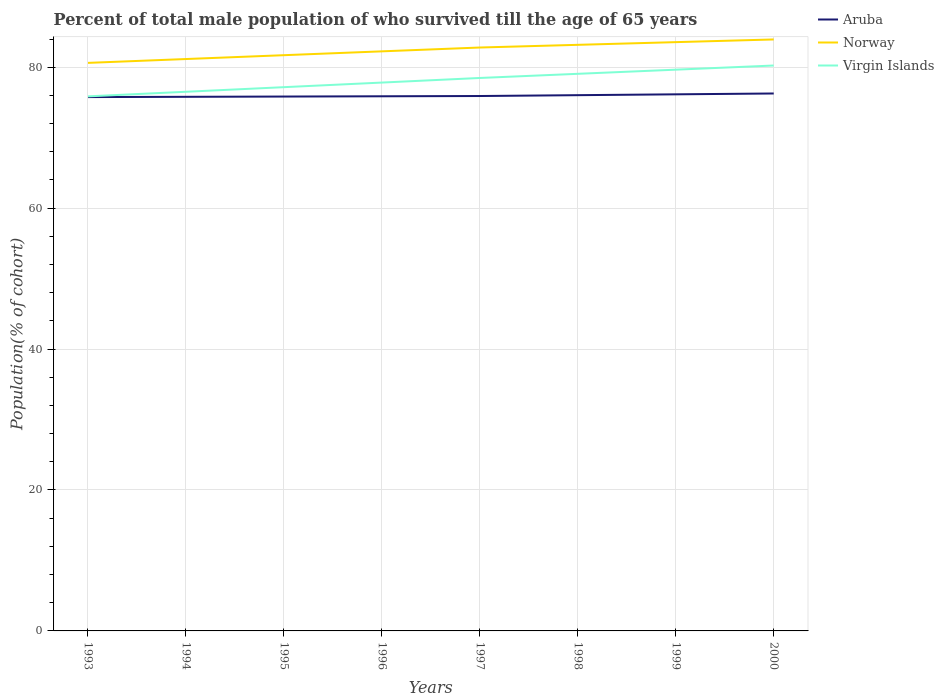How many different coloured lines are there?
Offer a very short reply. 3. Does the line corresponding to Virgin Islands intersect with the line corresponding to Aruba?
Provide a succinct answer. No. Is the number of lines equal to the number of legend labels?
Give a very brief answer. Yes. Across all years, what is the maximum percentage of total male population who survived till the age of 65 years in Norway?
Keep it short and to the point. 80.62. In which year was the percentage of total male population who survived till the age of 65 years in Virgin Islands maximum?
Offer a very short reply. 1993. What is the total percentage of total male population who survived till the age of 65 years in Norway in the graph?
Make the answer very short. -0.38. What is the difference between the highest and the second highest percentage of total male population who survived till the age of 65 years in Norway?
Your response must be concise. 3.32. What is the difference between the highest and the lowest percentage of total male population who survived till the age of 65 years in Norway?
Your answer should be very brief. 4. Is the percentage of total male population who survived till the age of 65 years in Virgin Islands strictly greater than the percentage of total male population who survived till the age of 65 years in Norway over the years?
Keep it short and to the point. Yes. How many lines are there?
Give a very brief answer. 3. What is the difference between two consecutive major ticks on the Y-axis?
Offer a very short reply. 20. Does the graph contain grids?
Your answer should be compact. Yes. Where does the legend appear in the graph?
Ensure brevity in your answer.  Top right. How many legend labels are there?
Your answer should be very brief. 3. What is the title of the graph?
Make the answer very short. Percent of total male population of who survived till the age of 65 years. What is the label or title of the X-axis?
Provide a succinct answer. Years. What is the label or title of the Y-axis?
Provide a short and direct response. Population(% of cohort). What is the Population(% of cohort) of Aruba in 1993?
Keep it short and to the point. 75.76. What is the Population(% of cohort) of Norway in 1993?
Give a very brief answer. 80.62. What is the Population(% of cohort) in Virgin Islands in 1993?
Provide a succinct answer. 75.87. What is the Population(% of cohort) in Aruba in 1994?
Provide a succinct answer. 75.8. What is the Population(% of cohort) in Norway in 1994?
Give a very brief answer. 81.16. What is the Population(% of cohort) of Virgin Islands in 1994?
Your response must be concise. 76.52. What is the Population(% of cohort) of Aruba in 1995?
Offer a terse response. 75.84. What is the Population(% of cohort) of Norway in 1995?
Your answer should be compact. 81.71. What is the Population(% of cohort) in Virgin Islands in 1995?
Your answer should be compact. 77.17. What is the Population(% of cohort) of Aruba in 1996?
Provide a short and direct response. 75.88. What is the Population(% of cohort) of Norway in 1996?
Give a very brief answer. 82.25. What is the Population(% of cohort) of Virgin Islands in 1996?
Provide a short and direct response. 77.82. What is the Population(% of cohort) of Aruba in 1997?
Provide a succinct answer. 75.92. What is the Population(% of cohort) of Norway in 1997?
Make the answer very short. 82.8. What is the Population(% of cohort) of Virgin Islands in 1997?
Keep it short and to the point. 78.48. What is the Population(% of cohort) of Aruba in 1998?
Make the answer very short. 76.03. What is the Population(% of cohort) of Norway in 1998?
Provide a succinct answer. 83.18. What is the Population(% of cohort) in Virgin Islands in 1998?
Give a very brief answer. 79.07. What is the Population(% of cohort) of Aruba in 1999?
Your answer should be compact. 76.15. What is the Population(% of cohort) of Norway in 1999?
Provide a succinct answer. 83.56. What is the Population(% of cohort) of Virgin Islands in 1999?
Offer a terse response. 79.65. What is the Population(% of cohort) of Aruba in 2000?
Provide a short and direct response. 76.27. What is the Population(% of cohort) of Norway in 2000?
Provide a short and direct response. 83.94. What is the Population(% of cohort) in Virgin Islands in 2000?
Your answer should be very brief. 80.24. Across all years, what is the maximum Population(% of cohort) in Aruba?
Offer a terse response. 76.27. Across all years, what is the maximum Population(% of cohort) of Norway?
Ensure brevity in your answer.  83.94. Across all years, what is the maximum Population(% of cohort) of Virgin Islands?
Offer a very short reply. 80.24. Across all years, what is the minimum Population(% of cohort) in Aruba?
Provide a short and direct response. 75.76. Across all years, what is the minimum Population(% of cohort) in Norway?
Provide a short and direct response. 80.62. Across all years, what is the minimum Population(% of cohort) of Virgin Islands?
Provide a succinct answer. 75.87. What is the total Population(% of cohort) in Aruba in the graph?
Provide a short and direct response. 607.66. What is the total Population(% of cohort) of Norway in the graph?
Your response must be concise. 659.23. What is the total Population(% of cohort) in Virgin Islands in the graph?
Provide a short and direct response. 624.82. What is the difference between the Population(% of cohort) in Aruba in 1993 and that in 1994?
Give a very brief answer. -0.04. What is the difference between the Population(% of cohort) in Norway in 1993 and that in 1994?
Your answer should be compact. -0.55. What is the difference between the Population(% of cohort) in Virgin Islands in 1993 and that in 1994?
Provide a succinct answer. -0.65. What is the difference between the Population(% of cohort) in Aruba in 1993 and that in 1995?
Ensure brevity in your answer.  -0.08. What is the difference between the Population(% of cohort) of Norway in 1993 and that in 1995?
Provide a short and direct response. -1.09. What is the difference between the Population(% of cohort) of Virgin Islands in 1993 and that in 1995?
Offer a very short reply. -1.31. What is the difference between the Population(% of cohort) of Aruba in 1993 and that in 1996?
Your response must be concise. -0.11. What is the difference between the Population(% of cohort) of Norway in 1993 and that in 1996?
Give a very brief answer. -1.64. What is the difference between the Population(% of cohort) of Virgin Islands in 1993 and that in 1996?
Ensure brevity in your answer.  -1.96. What is the difference between the Population(% of cohort) in Aruba in 1993 and that in 1997?
Offer a terse response. -0.15. What is the difference between the Population(% of cohort) of Norway in 1993 and that in 1997?
Your answer should be compact. -2.18. What is the difference between the Population(% of cohort) of Virgin Islands in 1993 and that in 1997?
Provide a succinct answer. -2.61. What is the difference between the Population(% of cohort) of Aruba in 1993 and that in 1998?
Ensure brevity in your answer.  -0.27. What is the difference between the Population(% of cohort) of Norway in 1993 and that in 1998?
Offer a terse response. -2.56. What is the difference between the Population(% of cohort) in Virgin Islands in 1993 and that in 1998?
Give a very brief answer. -3.2. What is the difference between the Population(% of cohort) in Aruba in 1993 and that in 1999?
Ensure brevity in your answer.  -0.39. What is the difference between the Population(% of cohort) of Norway in 1993 and that in 1999?
Your answer should be very brief. -2.94. What is the difference between the Population(% of cohort) of Virgin Islands in 1993 and that in 1999?
Your answer should be very brief. -3.79. What is the difference between the Population(% of cohort) of Aruba in 1993 and that in 2000?
Keep it short and to the point. -0.51. What is the difference between the Population(% of cohort) in Norway in 1993 and that in 2000?
Provide a short and direct response. -3.32. What is the difference between the Population(% of cohort) in Virgin Islands in 1993 and that in 2000?
Your answer should be compact. -4.38. What is the difference between the Population(% of cohort) in Aruba in 1994 and that in 1995?
Your response must be concise. -0.04. What is the difference between the Population(% of cohort) in Norway in 1994 and that in 1995?
Offer a very short reply. -0.55. What is the difference between the Population(% of cohort) in Virgin Islands in 1994 and that in 1995?
Your answer should be very brief. -0.65. What is the difference between the Population(% of cohort) in Aruba in 1994 and that in 1996?
Keep it short and to the point. -0.08. What is the difference between the Population(% of cohort) in Norway in 1994 and that in 1996?
Your response must be concise. -1.09. What is the difference between the Population(% of cohort) of Virgin Islands in 1994 and that in 1996?
Your answer should be very brief. -1.31. What is the difference between the Population(% of cohort) in Aruba in 1994 and that in 1997?
Your answer should be very brief. -0.11. What is the difference between the Population(% of cohort) in Norway in 1994 and that in 1997?
Give a very brief answer. -1.64. What is the difference between the Population(% of cohort) in Virgin Islands in 1994 and that in 1997?
Keep it short and to the point. -1.96. What is the difference between the Population(% of cohort) in Aruba in 1994 and that in 1998?
Offer a terse response. -0.23. What is the difference between the Population(% of cohort) of Norway in 1994 and that in 1998?
Your response must be concise. -2.02. What is the difference between the Population(% of cohort) of Virgin Islands in 1994 and that in 1998?
Provide a short and direct response. -2.55. What is the difference between the Population(% of cohort) of Aruba in 1994 and that in 1999?
Give a very brief answer. -0.35. What is the difference between the Population(% of cohort) in Norway in 1994 and that in 1999?
Your answer should be very brief. -2.4. What is the difference between the Population(% of cohort) of Virgin Islands in 1994 and that in 1999?
Give a very brief answer. -3.14. What is the difference between the Population(% of cohort) of Aruba in 1994 and that in 2000?
Give a very brief answer. -0.47. What is the difference between the Population(% of cohort) in Norway in 1994 and that in 2000?
Give a very brief answer. -2.78. What is the difference between the Population(% of cohort) of Virgin Islands in 1994 and that in 2000?
Your answer should be very brief. -3.73. What is the difference between the Population(% of cohort) of Aruba in 1995 and that in 1996?
Offer a very short reply. -0.04. What is the difference between the Population(% of cohort) in Norway in 1995 and that in 1996?
Make the answer very short. -0.55. What is the difference between the Population(% of cohort) in Virgin Islands in 1995 and that in 1996?
Ensure brevity in your answer.  -0.65. What is the difference between the Population(% of cohort) of Aruba in 1995 and that in 1997?
Provide a succinct answer. -0.08. What is the difference between the Population(% of cohort) in Norway in 1995 and that in 1997?
Ensure brevity in your answer.  -1.09. What is the difference between the Population(% of cohort) of Virgin Islands in 1995 and that in 1997?
Offer a very short reply. -1.31. What is the difference between the Population(% of cohort) of Aruba in 1995 and that in 1998?
Provide a short and direct response. -0.2. What is the difference between the Population(% of cohort) of Norway in 1995 and that in 1998?
Your answer should be compact. -1.47. What is the difference between the Population(% of cohort) of Virgin Islands in 1995 and that in 1998?
Provide a succinct answer. -1.89. What is the difference between the Population(% of cohort) of Aruba in 1995 and that in 1999?
Offer a very short reply. -0.32. What is the difference between the Population(% of cohort) of Norway in 1995 and that in 1999?
Your response must be concise. -1.85. What is the difference between the Population(% of cohort) of Virgin Islands in 1995 and that in 1999?
Offer a very short reply. -2.48. What is the difference between the Population(% of cohort) in Aruba in 1995 and that in 2000?
Your response must be concise. -0.43. What is the difference between the Population(% of cohort) of Norway in 1995 and that in 2000?
Provide a succinct answer. -2.23. What is the difference between the Population(% of cohort) in Virgin Islands in 1995 and that in 2000?
Keep it short and to the point. -3.07. What is the difference between the Population(% of cohort) of Aruba in 1996 and that in 1997?
Give a very brief answer. -0.04. What is the difference between the Population(% of cohort) of Norway in 1996 and that in 1997?
Provide a short and direct response. -0.55. What is the difference between the Population(% of cohort) in Virgin Islands in 1996 and that in 1997?
Your response must be concise. -0.65. What is the difference between the Population(% of cohort) of Aruba in 1996 and that in 1998?
Your answer should be compact. -0.16. What is the difference between the Population(% of cohort) in Norway in 1996 and that in 1998?
Keep it short and to the point. -0.93. What is the difference between the Population(% of cohort) in Virgin Islands in 1996 and that in 1998?
Your answer should be compact. -1.24. What is the difference between the Population(% of cohort) in Aruba in 1996 and that in 1999?
Offer a very short reply. -0.28. What is the difference between the Population(% of cohort) in Norway in 1996 and that in 1999?
Your answer should be very brief. -1.31. What is the difference between the Population(% of cohort) in Virgin Islands in 1996 and that in 1999?
Offer a very short reply. -1.83. What is the difference between the Population(% of cohort) in Aruba in 1996 and that in 2000?
Offer a terse response. -0.4. What is the difference between the Population(% of cohort) in Norway in 1996 and that in 2000?
Give a very brief answer. -1.69. What is the difference between the Population(% of cohort) in Virgin Islands in 1996 and that in 2000?
Offer a terse response. -2.42. What is the difference between the Population(% of cohort) of Aruba in 1997 and that in 1998?
Ensure brevity in your answer.  -0.12. What is the difference between the Population(% of cohort) in Norway in 1997 and that in 1998?
Make the answer very short. -0.38. What is the difference between the Population(% of cohort) of Virgin Islands in 1997 and that in 1998?
Your answer should be compact. -0.59. What is the difference between the Population(% of cohort) of Aruba in 1997 and that in 1999?
Your answer should be compact. -0.24. What is the difference between the Population(% of cohort) in Norway in 1997 and that in 1999?
Keep it short and to the point. -0.76. What is the difference between the Population(% of cohort) of Virgin Islands in 1997 and that in 1999?
Keep it short and to the point. -1.18. What is the difference between the Population(% of cohort) of Aruba in 1997 and that in 2000?
Provide a succinct answer. -0.36. What is the difference between the Population(% of cohort) of Norway in 1997 and that in 2000?
Your answer should be compact. -1.14. What is the difference between the Population(% of cohort) of Virgin Islands in 1997 and that in 2000?
Your answer should be compact. -1.77. What is the difference between the Population(% of cohort) in Aruba in 1998 and that in 1999?
Give a very brief answer. -0.12. What is the difference between the Population(% of cohort) in Norway in 1998 and that in 1999?
Your answer should be compact. -0.38. What is the difference between the Population(% of cohort) in Virgin Islands in 1998 and that in 1999?
Your answer should be compact. -0.59. What is the difference between the Population(% of cohort) of Aruba in 1998 and that in 2000?
Make the answer very short. -0.24. What is the difference between the Population(% of cohort) in Norway in 1998 and that in 2000?
Make the answer very short. -0.76. What is the difference between the Population(% of cohort) in Virgin Islands in 1998 and that in 2000?
Make the answer very short. -1.18. What is the difference between the Population(% of cohort) of Aruba in 1999 and that in 2000?
Give a very brief answer. -0.12. What is the difference between the Population(% of cohort) of Norway in 1999 and that in 2000?
Offer a terse response. -0.38. What is the difference between the Population(% of cohort) of Virgin Islands in 1999 and that in 2000?
Your response must be concise. -0.59. What is the difference between the Population(% of cohort) in Aruba in 1993 and the Population(% of cohort) in Norway in 1994?
Make the answer very short. -5.4. What is the difference between the Population(% of cohort) of Aruba in 1993 and the Population(% of cohort) of Virgin Islands in 1994?
Provide a succinct answer. -0.76. What is the difference between the Population(% of cohort) in Norway in 1993 and the Population(% of cohort) in Virgin Islands in 1994?
Your response must be concise. 4.1. What is the difference between the Population(% of cohort) of Aruba in 1993 and the Population(% of cohort) of Norway in 1995?
Ensure brevity in your answer.  -5.95. What is the difference between the Population(% of cohort) in Aruba in 1993 and the Population(% of cohort) in Virgin Islands in 1995?
Offer a very short reply. -1.41. What is the difference between the Population(% of cohort) of Norway in 1993 and the Population(% of cohort) of Virgin Islands in 1995?
Make the answer very short. 3.45. What is the difference between the Population(% of cohort) of Aruba in 1993 and the Population(% of cohort) of Norway in 1996?
Ensure brevity in your answer.  -6.49. What is the difference between the Population(% of cohort) in Aruba in 1993 and the Population(% of cohort) in Virgin Islands in 1996?
Your response must be concise. -2.06. What is the difference between the Population(% of cohort) in Norway in 1993 and the Population(% of cohort) in Virgin Islands in 1996?
Your response must be concise. 2.8. What is the difference between the Population(% of cohort) of Aruba in 1993 and the Population(% of cohort) of Norway in 1997?
Give a very brief answer. -7.04. What is the difference between the Population(% of cohort) in Aruba in 1993 and the Population(% of cohort) in Virgin Islands in 1997?
Keep it short and to the point. -2.71. What is the difference between the Population(% of cohort) of Norway in 1993 and the Population(% of cohort) of Virgin Islands in 1997?
Keep it short and to the point. 2.14. What is the difference between the Population(% of cohort) in Aruba in 1993 and the Population(% of cohort) in Norway in 1998?
Provide a succinct answer. -7.42. What is the difference between the Population(% of cohort) of Aruba in 1993 and the Population(% of cohort) of Virgin Islands in 1998?
Provide a short and direct response. -3.3. What is the difference between the Population(% of cohort) of Norway in 1993 and the Population(% of cohort) of Virgin Islands in 1998?
Ensure brevity in your answer.  1.55. What is the difference between the Population(% of cohort) in Aruba in 1993 and the Population(% of cohort) in Norway in 1999?
Your answer should be compact. -7.8. What is the difference between the Population(% of cohort) in Aruba in 1993 and the Population(% of cohort) in Virgin Islands in 1999?
Give a very brief answer. -3.89. What is the difference between the Population(% of cohort) of Norway in 1993 and the Population(% of cohort) of Virgin Islands in 1999?
Ensure brevity in your answer.  0.96. What is the difference between the Population(% of cohort) in Aruba in 1993 and the Population(% of cohort) in Norway in 2000?
Ensure brevity in your answer.  -8.18. What is the difference between the Population(% of cohort) of Aruba in 1993 and the Population(% of cohort) of Virgin Islands in 2000?
Offer a very short reply. -4.48. What is the difference between the Population(% of cohort) in Norway in 1993 and the Population(% of cohort) in Virgin Islands in 2000?
Provide a short and direct response. 0.38. What is the difference between the Population(% of cohort) in Aruba in 1994 and the Population(% of cohort) in Norway in 1995?
Provide a short and direct response. -5.91. What is the difference between the Population(% of cohort) in Aruba in 1994 and the Population(% of cohort) in Virgin Islands in 1995?
Give a very brief answer. -1.37. What is the difference between the Population(% of cohort) of Norway in 1994 and the Population(% of cohort) of Virgin Islands in 1995?
Provide a short and direct response. 3.99. What is the difference between the Population(% of cohort) in Aruba in 1994 and the Population(% of cohort) in Norway in 1996?
Offer a very short reply. -6.45. What is the difference between the Population(% of cohort) in Aruba in 1994 and the Population(% of cohort) in Virgin Islands in 1996?
Your response must be concise. -2.02. What is the difference between the Population(% of cohort) in Norway in 1994 and the Population(% of cohort) in Virgin Islands in 1996?
Your answer should be very brief. 3.34. What is the difference between the Population(% of cohort) of Aruba in 1994 and the Population(% of cohort) of Norway in 1997?
Make the answer very short. -7. What is the difference between the Population(% of cohort) in Aruba in 1994 and the Population(% of cohort) in Virgin Islands in 1997?
Your response must be concise. -2.68. What is the difference between the Population(% of cohort) of Norway in 1994 and the Population(% of cohort) of Virgin Islands in 1997?
Provide a succinct answer. 2.69. What is the difference between the Population(% of cohort) of Aruba in 1994 and the Population(% of cohort) of Norway in 1998?
Your answer should be very brief. -7.38. What is the difference between the Population(% of cohort) of Aruba in 1994 and the Population(% of cohort) of Virgin Islands in 1998?
Provide a short and direct response. -3.26. What is the difference between the Population(% of cohort) of Norway in 1994 and the Population(% of cohort) of Virgin Islands in 1998?
Your answer should be compact. 2.1. What is the difference between the Population(% of cohort) in Aruba in 1994 and the Population(% of cohort) in Norway in 1999?
Provide a succinct answer. -7.76. What is the difference between the Population(% of cohort) in Aruba in 1994 and the Population(% of cohort) in Virgin Islands in 1999?
Your response must be concise. -3.85. What is the difference between the Population(% of cohort) of Norway in 1994 and the Population(% of cohort) of Virgin Islands in 1999?
Your answer should be very brief. 1.51. What is the difference between the Population(% of cohort) in Aruba in 1994 and the Population(% of cohort) in Norway in 2000?
Your response must be concise. -8.14. What is the difference between the Population(% of cohort) in Aruba in 1994 and the Population(% of cohort) in Virgin Islands in 2000?
Ensure brevity in your answer.  -4.44. What is the difference between the Population(% of cohort) in Norway in 1994 and the Population(% of cohort) in Virgin Islands in 2000?
Offer a terse response. 0.92. What is the difference between the Population(% of cohort) in Aruba in 1995 and the Population(% of cohort) in Norway in 1996?
Give a very brief answer. -6.41. What is the difference between the Population(% of cohort) in Aruba in 1995 and the Population(% of cohort) in Virgin Islands in 1996?
Your answer should be compact. -1.98. What is the difference between the Population(% of cohort) in Norway in 1995 and the Population(% of cohort) in Virgin Islands in 1996?
Your response must be concise. 3.89. What is the difference between the Population(% of cohort) in Aruba in 1995 and the Population(% of cohort) in Norway in 1997?
Make the answer very short. -6.96. What is the difference between the Population(% of cohort) of Aruba in 1995 and the Population(% of cohort) of Virgin Islands in 1997?
Provide a succinct answer. -2.64. What is the difference between the Population(% of cohort) in Norway in 1995 and the Population(% of cohort) in Virgin Islands in 1997?
Make the answer very short. 3.23. What is the difference between the Population(% of cohort) of Aruba in 1995 and the Population(% of cohort) of Norway in 1998?
Your answer should be very brief. -7.34. What is the difference between the Population(% of cohort) of Aruba in 1995 and the Population(% of cohort) of Virgin Islands in 1998?
Provide a short and direct response. -3.23. What is the difference between the Population(% of cohort) of Norway in 1995 and the Population(% of cohort) of Virgin Islands in 1998?
Make the answer very short. 2.64. What is the difference between the Population(% of cohort) in Aruba in 1995 and the Population(% of cohort) in Norway in 1999?
Offer a terse response. -7.72. What is the difference between the Population(% of cohort) in Aruba in 1995 and the Population(% of cohort) in Virgin Islands in 1999?
Offer a very short reply. -3.82. What is the difference between the Population(% of cohort) in Norway in 1995 and the Population(% of cohort) in Virgin Islands in 1999?
Give a very brief answer. 2.05. What is the difference between the Population(% of cohort) in Aruba in 1995 and the Population(% of cohort) in Norway in 2000?
Ensure brevity in your answer.  -8.1. What is the difference between the Population(% of cohort) of Aruba in 1995 and the Population(% of cohort) of Virgin Islands in 2000?
Keep it short and to the point. -4.4. What is the difference between the Population(% of cohort) in Norway in 1995 and the Population(% of cohort) in Virgin Islands in 2000?
Keep it short and to the point. 1.47. What is the difference between the Population(% of cohort) of Aruba in 1996 and the Population(% of cohort) of Norway in 1997?
Your response must be concise. -6.92. What is the difference between the Population(% of cohort) of Aruba in 1996 and the Population(% of cohort) of Virgin Islands in 1997?
Give a very brief answer. -2.6. What is the difference between the Population(% of cohort) in Norway in 1996 and the Population(% of cohort) in Virgin Islands in 1997?
Your response must be concise. 3.78. What is the difference between the Population(% of cohort) in Aruba in 1996 and the Population(% of cohort) in Norway in 1998?
Your answer should be very brief. -7.3. What is the difference between the Population(% of cohort) of Aruba in 1996 and the Population(% of cohort) of Virgin Islands in 1998?
Your answer should be very brief. -3.19. What is the difference between the Population(% of cohort) of Norway in 1996 and the Population(% of cohort) of Virgin Islands in 1998?
Give a very brief answer. 3.19. What is the difference between the Population(% of cohort) of Aruba in 1996 and the Population(% of cohort) of Norway in 1999?
Ensure brevity in your answer.  -7.68. What is the difference between the Population(% of cohort) of Aruba in 1996 and the Population(% of cohort) of Virgin Islands in 1999?
Provide a short and direct response. -3.78. What is the difference between the Population(% of cohort) of Norway in 1996 and the Population(% of cohort) of Virgin Islands in 1999?
Your answer should be very brief. 2.6. What is the difference between the Population(% of cohort) of Aruba in 1996 and the Population(% of cohort) of Norway in 2000?
Provide a succinct answer. -8.06. What is the difference between the Population(% of cohort) in Aruba in 1996 and the Population(% of cohort) in Virgin Islands in 2000?
Your answer should be very brief. -4.37. What is the difference between the Population(% of cohort) in Norway in 1996 and the Population(% of cohort) in Virgin Islands in 2000?
Offer a very short reply. 2.01. What is the difference between the Population(% of cohort) in Aruba in 1997 and the Population(% of cohort) in Norway in 1998?
Keep it short and to the point. -7.26. What is the difference between the Population(% of cohort) in Aruba in 1997 and the Population(% of cohort) in Virgin Islands in 1998?
Give a very brief answer. -3.15. What is the difference between the Population(% of cohort) in Norway in 1997 and the Population(% of cohort) in Virgin Islands in 1998?
Offer a very short reply. 3.73. What is the difference between the Population(% of cohort) of Aruba in 1997 and the Population(% of cohort) of Norway in 1999?
Your answer should be compact. -7.65. What is the difference between the Population(% of cohort) of Aruba in 1997 and the Population(% of cohort) of Virgin Islands in 1999?
Offer a very short reply. -3.74. What is the difference between the Population(% of cohort) in Norway in 1997 and the Population(% of cohort) in Virgin Islands in 1999?
Your answer should be very brief. 3.14. What is the difference between the Population(% of cohort) in Aruba in 1997 and the Population(% of cohort) in Norway in 2000?
Your response must be concise. -8.03. What is the difference between the Population(% of cohort) in Aruba in 1997 and the Population(% of cohort) in Virgin Islands in 2000?
Your response must be concise. -4.33. What is the difference between the Population(% of cohort) of Norway in 1997 and the Population(% of cohort) of Virgin Islands in 2000?
Offer a terse response. 2.56. What is the difference between the Population(% of cohort) of Aruba in 1998 and the Population(% of cohort) of Norway in 1999?
Make the answer very short. -7.53. What is the difference between the Population(% of cohort) of Aruba in 1998 and the Population(% of cohort) of Virgin Islands in 1999?
Provide a short and direct response. -3.62. What is the difference between the Population(% of cohort) of Norway in 1998 and the Population(% of cohort) of Virgin Islands in 1999?
Offer a terse response. 3.53. What is the difference between the Population(% of cohort) in Aruba in 1998 and the Population(% of cohort) in Norway in 2000?
Your response must be concise. -7.91. What is the difference between the Population(% of cohort) in Aruba in 1998 and the Population(% of cohort) in Virgin Islands in 2000?
Offer a very short reply. -4.21. What is the difference between the Population(% of cohort) of Norway in 1998 and the Population(% of cohort) of Virgin Islands in 2000?
Your answer should be compact. 2.94. What is the difference between the Population(% of cohort) in Aruba in 1999 and the Population(% of cohort) in Norway in 2000?
Provide a short and direct response. -7.79. What is the difference between the Population(% of cohort) of Aruba in 1999 and the Population(% of cohort) of Virgin Islands in 2000?
Offer a very short reply. -4.09. What is the difference between the Population(% of cohort) of Norway in 1999 and the Population(% of cohort) of Virgin Islands in 2000?
Provide a succinct answer. 3.32. What is the average Population(% of cohort) of Aruba per year?
Ensure brevity in your answer.  75.96. What is the average Population(% of cohort) of Norway per year?
Your answer should be compact. 82.4. What is the average Population(% of cohort) in Virgin Islands per year?
Offer a terse response. 78.1. In the year 1993, what is the difference between the Population(% of cohort) of Aruba and Population(% of cohort) of Norway?
Ensure brevity in your answer.  -4.86. In the year 1993, what is the difference between the Population(% of cohort) in Aruba and Population(% of cohort) in Virgin Islands?
Provide a short and direct response. -0.1. In the year 1993, what is the difference between the Population(% of cohort) in Norway and Population(% of cohort) in Virgin Islands?
Make the answer very short. 4.75. In the year 1994, what is the difference between the Population(% of cohort) in Aruba and Population(% of cohort) in Norway?
Your answer should be compact. -5.36. In the year 1994, what is the difference between the Population(% of cohort) in Aruba and Population(% of cohort) in Virgin Islands?
Make the answer very short. -0.72. In the year 1994, what is the difference between the Population(% of cohort) in Norway and Population(% of cohort) in Virgin Islands?
Offer a terse response. 4.65. In the year 1995, what is the difference between the Population(% of cohort) in Aruba and Population(% of cohort) in Norway?
Your response must be concise. -5.87. In the year 1995, what is the difference between the Population(% of cohort) in Aruba and Population(% of cohort) in Virgin Islands?
Provide a short and direct response. -1.33. In the year 1995, what is the difference between the Population(% of cohort) in Norway and Population(% of cohort) in Virgin Islands?
Make the answer very short. 4.54. In the year 1996, what is the difference between the Population(% of cohort) of Aruba and Population(% of cohort) of Norway?
Provide a short and direct response. -6.38. In the year 1996, what is the difference between the Population(% of cohort) of Aruba and Population(% of cohort) of Virgin Islands?
Your answer should be compact. -1.95. In the year 1996, what is the difference between the Population(% of cohort) of Norway and Population(% of cohort) of Virgin Islands?
Provide a short and direct response. 4.43. In the year 1997, what is the difference between the Population(% of cohort) in Aruba and Population(% of cohort) in Norway?
Your response must be concise. -6.88. In the year 1997, what is the difference between the Population(% of cohort) in Aruba and Population(% of cohort) in Virgin Islands?
Your answer should be very brief. -2.56. In the year 1997, what is the difference between the Population(% of cohort) in Norway and Population(% of cohort) in Virgin Islands?
Make the answer very short. 4.32. In the year 1998, what is the difference between the Population(% of cohort) in Aruba and Population(% of cohort) in Norway?
Give a very brief answer. -7.15. In the year 1998, what is the difference between the Population(% of cohort) of Aruba and Population(% of cohort) of Virgin Islands?
Offer a very short reply. -3.03. In the year 1998, what is the difference between the Population(% of cohort) in Norway and Population(% of cohort) in Virgin Islands?
Keep it short and to the point. 4.11. In the year 1999, what is the difference between the Population(% of cohort) of Aruba and Population(% of cohort) of Norway?
Offer a very short reply. -7.41. In the year 1999, what is the difference between the Population(% of cohort) of Aruba and Population(% of cohort) of Virgin Islands?
Keep it short and to the point. -3.5. In the year 1999, what is the difference between the Population(% of cohort) in Norway and Population(% of cohort) in Virgin Islands?
Give a very brief answer. 3.91. In the year 2000, what is the difference between the Population(% of cohort) of Aruba and Population(% of cohort) of Norway?
Provide a short and direct response. -7.67. In the year 2000, what is the difference between the Population(% of cohort) in Aruba and Population(% of cohort) in Virgin Islands?
Give a very brief answer. -3.97. In the year 2000, what is the difference between the Population(% of cohort) of Norway and Population(% of cohort) of Virgin Islands?
Make the answer very short. 3.7. What is the ratio of the Population(% of cohort) in Aruba in 1993 to that in 1994?
Provide a short and direct response. 1. What is the ratio of the Population(% of cohort) of Aruba in 1993 to that in 1995?
Your response must be concise. 1. What is the ratio of the Population(% of cohort) of Norway in 1993 to that in 1995?
Give a very brief answer. 0.99. What is the ratio of the Population(% of cohort) in Virgin Islands in 1993 to that in 1995?
Your response must be concise. 0.98. What is the ratio of the Population(% of cohort) of Norway in 1993 to that in 1996?
Provide a short and direct response. 0.98. What is the ratio of the Population(% of cohort) of Virgin Islands in 1993 to that in 1996?
Your response must be concise. 0.97. What is the ratio of the Population(% of cohort) of Aruba in 1993 to that in 1997?
Provide a short and direct response. 1. What is the ratio of the Population(% of cohort) in Norway in 1993 to that in 1997?
Offer a terse response. 0.97. What is the ratio of the Population(% of cohort) in Virgin Islands in 1993 to that in 1997?
Give a very brief answer. 0.97. What is the ratio of the Population(% of cohort) of Aruba in 1993 to that in 1998?
Offer a very short reply. 1. What is the ratio of the Population(% of cohort) of Norway in 1993 to that in 1998?
Offer a terse response. 0.97. What is the ratio of the Population(% of cohort) in Virgin Islands in 1993 to that in 1998?
Give a very brief answer. 0.96. What is the ratio of the Population(% of cohort) in Norway in 1993 to that in 1999?
Provide a succinct answer. 0.96. What is the ratio of the Population(% of cohort) in Aruba in 1993 to that in 2000?
Offer a terse response. 0.99. What is the ratio of the Population(% of cohort) in Norway in 1993 to that in 2000?
Your answer should be very brief. 0.96. What is the ratio of the Population(% of cohort) of Virgin Islands in 1993 to that in 2000?
Keep it short and to the point. 0.95. What is the ratio of the Population(% of cohort) in Aruba in 1994 to that in 1995?
Make the answer very short. 1. What is the ratio of the Population(% of cohort) in Virgin Islands in 1994 to that in 1995?
Provide a succinct answer. 0.99. What is the ratio of the Population(% of cohort) of Aruba in 1994 to that in 1996?
Your response must be concise. 1. What is the ratio of the Population(% of cohort) of Norway in 1994 to that in 1996?
Your response must be concise. 0.99. What is the ratio of the Population(% of cohort) in Virgin Islands in 1994 to that in 1996?
Give a very brief answer. 0.98. What is the ratio of the Population(% of cohort) in Norway in 1994 to that in 1997?
Your answer should be compact. 0.98. What is the ratio of the Population(% of cohort) of Virgin Islands in 1994 to that in 1997?
Provide a succinct answer. 0.98. What is the ratio of the Population(% of cohort) of Aruba in 1994 to that in 1998?
Your answer should be very brief. 1. What is the ratio of the Population(% of cohort) of Norway in 1994 to that in 1998?
Your answer should be very brief. 0.98. What is the ratio of the Population(% of cohort) in Virgin Islands in 1994 to that in 1998?
Provide a short and direct response. 0.97. What is the ratio of the Population(% of cohort) of Aruba in 1994 to that in 1999?
Your answer should be very brief. 1. What is the ratio of the Population(% of cohort) of Norway in 1994 to that in 1999?
Give a very brief answer. 0.97. What is the ratio of the Population(% of cohort) of Virgin Islands in 1994 to that in 1999?
Your answer should be compact. 0.96. What is the ratio of the Population(% of cohort) of Aruba in 1994 to that in 2000?
Give a very brief answer. 0.99. What is the ratio of the Population(% of cohort) in Norway in 1994 to that in 2000?
Your answer should be very brief. 0.97. What is the ratio of the Population(% of cohort) of Virgin Islands in 1994 to that in 2000?
Your response must be concise. 0.95. What is the ratio of the Population(% of cohort) of Aruba in 1995 to that in 1996?
Offer a very short reply. 1. What is the ratio of the Population(% of cohort) in Norway in 1995 to that in 1996?
Provide a succinct answer. 0.99. What is the ratio of the Population(% of cohort) in Virgin Islands in 1995 to that in 1996?
Offer a very short reply. 0.99. What is the ratio of the Population(% of cohort) of Aruba in 1995 to that in 1997?
Offer a very short reply. 1. What is the ratio of the Population(% of cohort) in Norway in 1995 to that in 1997?
Offer a very short reply. 0.99. What is the ratio of the Population(% of cohort) of Virgin Islands in 1995 to that in 1997?
Offer a terse response. 0.98. What is the ratio of the Population(% of cohort) in Norway in 1995 to that in 1998?
Provide a succinct answer. 0.98. What is the ratio of the Population(% of cohort) of Virgin Islands in 1995 to that in 1998?
Your answer should be compact. 0.98. What is the ratio of the Population(% of cohort) in Norway in 1995 to that in 1999?
Ensure brevity in your answer.  0.98. What is the ratio of the Population(% of cohort) in Virgin Islands in 1995 to that in 1999?
Your answer should be compact. 0.97. What is the ratio of the Population(% of cohort) of Norway in 1995 to that in 2000?
Keep it short and to the point. 0.97. What is the ratio of the Population(% of cohort) in Virgin Islands in 1995 to that in 2000?
Give a very brief answer. 0.96. What is the ratio of the Population(% of cohort) in Norway in 1996 to that in 1997?
Keep it short and to the point. 0.99. What is the ratio of the Population(% of cohort) in Norway in 1996 to that in 1998?
Provide a short and direct response. 0.99. What is the ratio of the Population(% of cohort) in Virgin Islands in 1996 to that in 1998?
Your answer should be very brief. 0.98. What is the ratio of the Population(% of cohort) in Aruba in 1996 to that in 1999?
Provide a succinct answer. 1. What is the ratio of the Population(% of cohort) in Norway in 1996 to that in 1999?
Offer a very short reply. 0.98. What is the ratio of the Population(% of cohort) in Virgin Islands in 1996 to that in 1999?
Make the answer very short. 0.98. What is the ratio of the Population(% of cohort) in Aruba in 1996 to that in 2000?
Your answer should be compact. 0.99. What is the ratio of the Population(% of cohort) in Norway in 1996 to that in 2000?
Give a very brief answer. 0.98. What is the ratio of the Population(% of cohort) in Virgin Islands in 1996 to that in 2000?
Ensure brevity in your answer.  0.97. What is the ratio of the Population(% of cohort) of Aruba in 1997 to that in 1998?
Ensure brevity in your answer.  1. What is the ratio of the Population(% of cohort) in Norway in 1997 to that in 1998?
Your response must be concise. 1. What is the ratio of the Population(% of cohort) of Aruba in 1997 to that in 1999?
Keep it short and to the point. 1. What is the ratio of the Population(% of cohort) of Norway in 1997 to that in 1999?
Your answer should be very brief. 0.99. What is the ratio of the Population(% of cohort) in Virgin Islands in 1997 to that in 1999?
Give a very brief answer. 0.99. What is the ratio of the Population(% of cohort) of Aruba in 1997 to that in 2000?
Offer a terse response. 1. What is the ratio of the Population(% of cohort) in Norway in 1997 to that in 2000?
Your answer should be compact. 0.99. What is the ratio of the Population(% of cohort) of Virgin Islands in 1997 to that in 2000?
Your response must be concise. 0.98. What is the ratio of the Population(% of cohort) of Aruba in 1998 to that in 1999?
Ensure brevity in your answer.  1. What is the ratio of the Population(% of cohort) of Aruba in 1998 to that in 2000?
Give a very brief answer. 1. What is the ratio of the Population(% of cohort) in Norway in 1998 to that in 2000?
Ensure brevity in your answer.  0.99. What is the ratio of the Population(% of cohort) in Virgin Islands in 1998 to that in 2000?
Provide a succinct answer. 0.99. What is the ratio of the Population(% of cohort) in Virgin Islands in 1999 to that in 2000?
Give a very brief answer. 0.99. What is the difference between the highest and the second highest Population(% of cohort) of Aruba?
Make the answer very short. 0.12. What is the difference between the highest and the second highest Population(% of cohort) in Norway?
Keep it short and to the point. 0.38. What is the difference between the highest and the second highest Population(% of cohort) in Virgin Islands?
Offer a very short reply. 0.59. What is the difference between the highest and the lowest Population(% of cohort) of Aruba?
Your answer should be compact. 0.51. What is the difference between the highest and the lowest Population(% of cohort) in Norway?
Give a very brief answer. 3.32. What is the difference between the highest and the lowest Population(% of cohort) of Virgin Islands?
Offer a terse response. 4.38. 